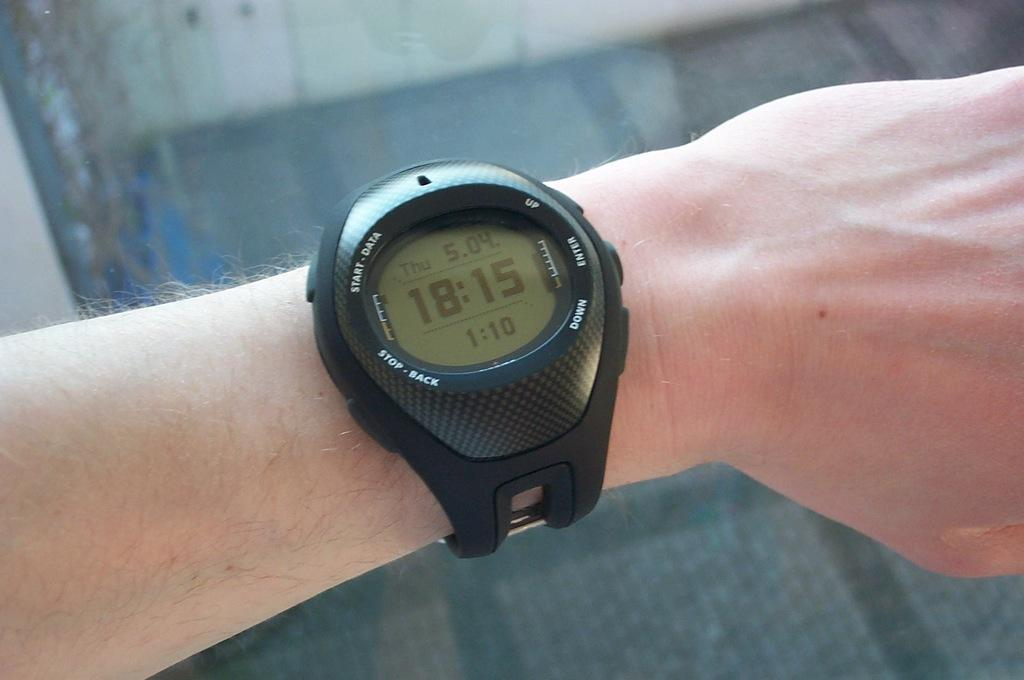<image>
Describe the image concisely. A digital watch face displays the time of 18:15. 